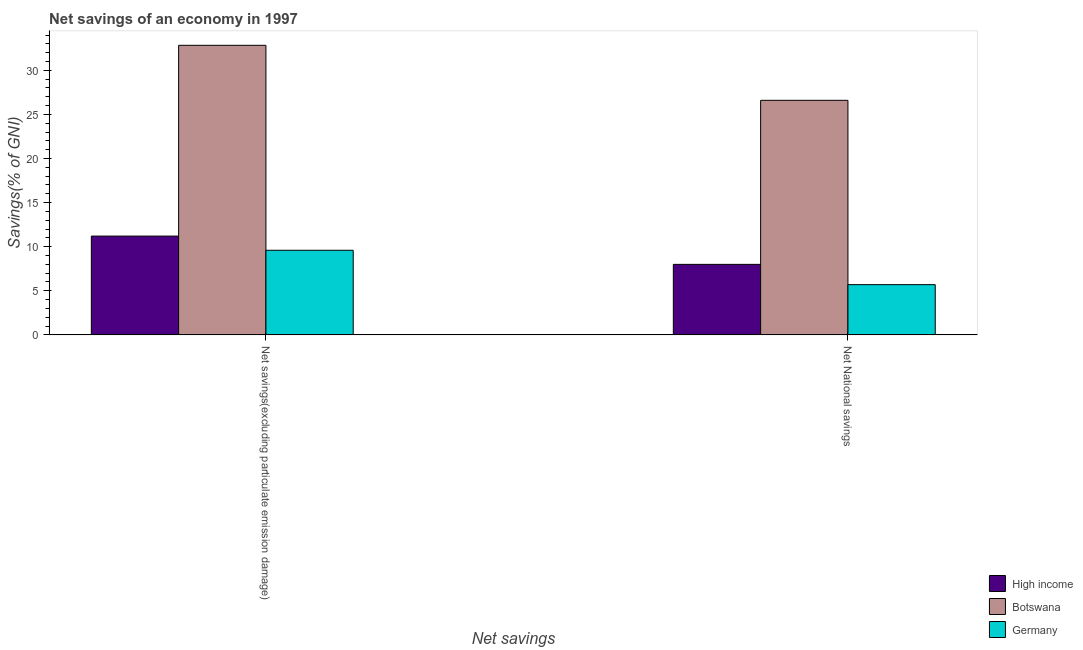How many groups of bars are there?
Provide a short and direct response. 2. Are the number of bars on each tick of the X-axis equal?
Your answer should be compact. Yes. What is the label of the 1st group of bars from the left?
Provide a succinct answer. Net savings(excluding particulate emission damage). What is the net savings(excluding particulate emission damage) in Botswana?
Keep it short and to the point. 32.84. Across all countries, what is the maximum net savings(excluding particulate emission damage)?
Offer a terse response. 32.84. Across all countries, what is the minimum net national savings?
Offer a terse response. 5.7. In which country was the net savings(excluding particulate emission damage) maximum?
Your answer should be compact. Botswana. What is the total net national savings in the graph?
Your response must be concise. 40.3. What is the difference between the net savings(excluding particulate emission damage) in Germany and that in Botswana?
Your response must be concise. -23.24. What is the difference between the net national savings in Germany and the net savings(excluding particulate emission damage) in High income?
Provide a short and direct response. -5.51. What is the average net national savings per country?
Give a very brief answer. 13.43. What is the difference between the net national savings and net savings(excluding particulate emission damage) in Botswana?
Provide a succinct answer. -6.24. What is the ratio of the net national savings in High income to that in Germany?
Ensure brevity in your answer.  1.4. Is the net national savings in Germany less than that in High income?
Keep it short and to the point. Yes. What does the 3rd bar from the left in Net savings(excluding particulate emission damage) represents?
Provide a succinct answer. Germany. What does the 2nd bar from the right in Net savings(excluding particulate emission damage) represents?
Provide a succinct answer. Botswana. How many bars are there?
Your response must be concise. 6. Are all the bars in the graph horizontal?
Provide a short and direct response. No. How many countries are there in the graph?
Keep it short and to the point. 3. What is the difference between two consecutive major ticks on the Y-axis?
Keep it short and to the point. 5. Where does the legend appear in the graph?
Offer a terse response. Bottom right. How are the legend labels stacked?
Your response must be concise. Vertical. What is the title of the graph?
Give a very brief answer. Net savings of an economy in 1997. Does "Cyprus" appear as one of the legend labels in the graph?
Give a very brief answer. No. What is the label or title of the X-axis?
Keep it short and to the point. Net savings. What is the label or title of the Y-axis?
Make the answer very short. Savings(% of GNI). What is the Savings(% of GNI) of High income in Net savings(excluding particulate emission damage)?
Give a very brief answer. 11.2. What is the Savings(% of GNI) in Botswana in Net savings(excluding particulate emission damage)?
Give a very brief answer. 32.84. What is the Savings(% of GNI) of Germany in Net savings(excluding particulate emission damage)?
Offer a very short reply. 9.6. What is the Savings(% of GNI) in High income in Net National savings?
Ensure brevity in your answer.  8. What is the Savings(% of GNI) in Botswana in Net National savings?
Your response must be concise. 26.6. What is the Savings(% of GNI) in Germany in Net National savings?
Offer a very short reply. 5.7. Across all Net savings, what is the maximum Savings(% of GNI) in High income?
Your answer should be very brief. 11.2. Across all Net savings, what is the maximum Savings(% of GNI) in Botswana?
Ensure brevity in your answer.  32.84. Across all Net savings, what is the maximum Savings(% of GNI) of Germany?
Your response must be concise. 9.6. Across all Net savings, what is the minimum Savings(% of GNI) in High income?
Keep it short and to the point. 8. Across all Net savings, what is the minimum Savings(% of GNI) of Botswana?
Make the answer very short. 26.6. Across all Net savings, what is the minimum Savings(% of GNI) in Germany?
Make the answer very short. 5.7. What is the total Savings(% of GNI) of High income in the graph?
Give a very brief answer. 19.2. What is the total Savings(% of GNI) of Botswana in the graph?
Give a very brief answer. 59.44. What is the total Savings(% of GNI) in Germany in the graph?
Give a very brief answer. 15.29. What is the difference between the Savings(% of GNI) in High income in Net savings(excluding particulate emission damage) and that in Net National savings?
Provide a succinct answer. 3.21. What is the difference between the Savings(% of GNI) of Botswana in Net savings(excluding particulate emission damage) and that in Net National savings?
Offer a very short reply. 6.24. What is the difference between the Savings(% of GNI) of Germany in Net savings(excluding particulate emission damage) and that in Net National savings?
Keep it short and to the point. 3.9. What is the difference between the Savings(% of GNI) of High income in Net savings(excluding particulate emission damage) and the Savings(% of GNI) of Botswana in Net National savings?
Offer a very short reply. -15.4. What is the difference between the Savings(% of GNI) of High income in Net savings(excluding particulate emission damage) and the Savings(% of GNI) of Germany in Net National savings?
Provide a short and direct response. 5.51. What is the difference between the Savings(% of GNI) in Botswana in Net savings(excluding particulate emission damage) and the Savings(% of GNI) in Germany in Net National savings?
Provide a short and direct response. 27.14. What is the average Savings(% of GNI) in High income per Net savings?
Your response must be concise. 9.6. What is the average Savings(% of GNI) of Botswana per Net savings?
Give a very brief answer. 29.72. What is the average Savings(% of GNI) of Germany per Net savings?
Make the answer very short. 7.65. What is the difference between the Savings(% of GNI) of High income and Savings(% of GNI) of Botswana in Net savings(excluding particulate emission damage)?
Your answer should be very brief. -21.64. What is the difference between the Savings(% of GNI) in High income and Savings(% of GNI) in Germany in Net savings(excluding particulate emission damage)?
Make the answer very short. 1.61. What is the difference between the Savings(% of GNI) of Botswana and Savings(% of GNI) of Germany in Net savings(excluding particulate emission damage)?
Give a very brief answer. 23.24. What is the difference between the Savings(% of GNI) in High income and Savings(% of GNI) in Botswana in Net National savings?
Keep it short and to the point. -18.61. What is the difference between the Savings(% of GNI) of High income and Savings(% of GNI) of Germany in Net National savings?
Your answer should be very brief. 2.3. What is the difference between the Savings(% of GNI) in Botswana and Savings(% of GNI) in Germany in Net National savings?
Your answer should be compact. 20.9. What is the ratio of the Savings(% of GNI) of High income in Net savings(excluding particulate emission damage) to that in Net National savings?
Give a very brief answer. 1.4. What is the ratio of the Savings(% of GNI) of Botswana in Net savings(excluding particulate emission damage) to that in Net National savings?
Ensure brevity in your answer.  1.23. What is the ratio of the Savings(% of GNI) of Germany in Net savings(excluding particulate emission damage) to that in Net National savings?
Provide a short and direct response. 1.68. What is the difference between the highest and the second highest Savings(% of GNI) of High income?
Your response must be concise. 3.21. What is the difference between the highest and the second highest Savings(% of GNI) of Botswana?
Keep it short and to the point. 6.24. What is the difference between the highest and the second highest Savings(% of GNI) of Germany?
Your answer should be compact. 3.9. What is the difference between the highest and the lowest Savings(% of GNI) of High income?
Your answer should be very brief. 3.21. What is the difference between the highest and the lowest Savings(% of GNI) of Botswana?
Your answer should be compact. 6.24. What is the difference between the highest and the lowest Savings(% of GNI) of Germany?
Offer a terse response. 3.9. 